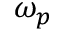<formula> <loc_0><loc_0><loc_500><loc_500>\omega _ { p }</formula> 